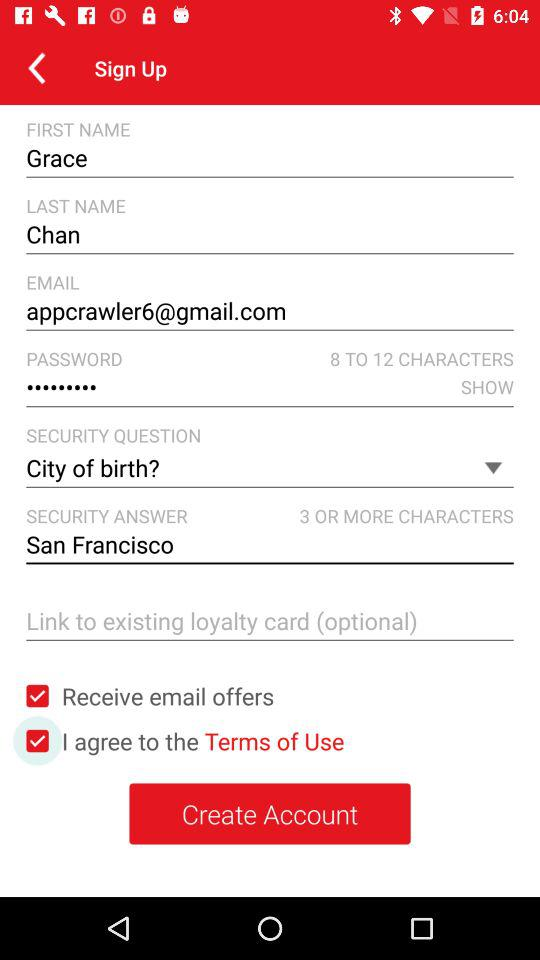What is the status of "Receive email offers"? The status of "Receive email offers" is "on". 